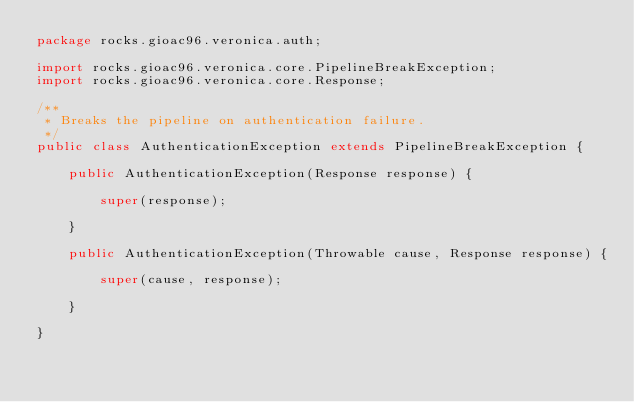<code> <loc_0><loc_0><loc_500><loc_500><_Java_>package rocks.gioac96.veronica.auth;

import rocks.gioac96.veronica.core.PipelineBreakException;
import rocks.gioac96.veronica.core.Response;

/**
 * Breaks the pipeline on authentication failure.
 */
public class AuthenticationException extends PipelineBreakException {

    public AuthenticationException(Response response) {

        super(response);

    }

    public AuthenticationException(Throwable cause, Response response) {

        super(cause, response);

    }

}
</code> 